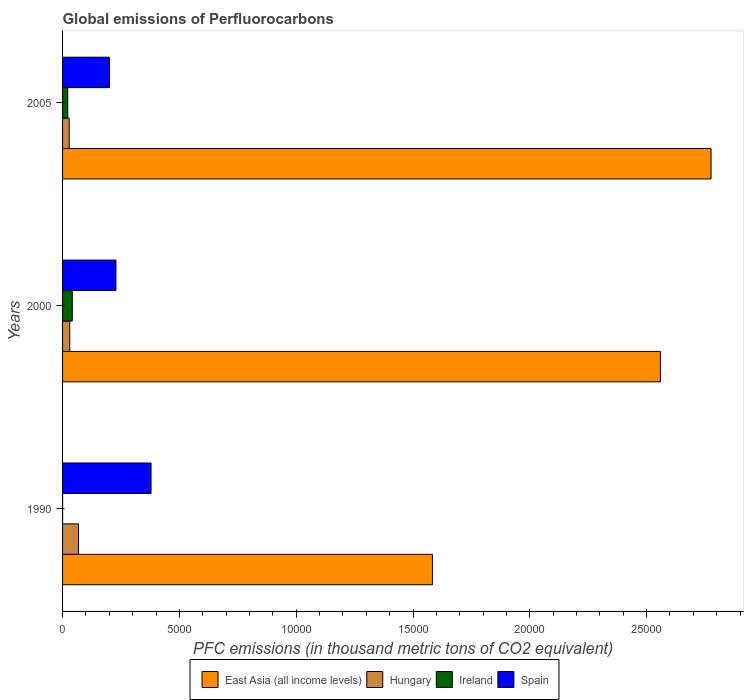How many groups of bars are there?
Give a very brief answer. 3. Are the number of bars on each tick of the Y-axis equal?
Your answer should be compact. Yes. How many bars are there on the 2nd tick from the bottom?
Your answer should be compact. 4. What is the global emissions of Perfluorocarbons in East Asia (all income levels) in 2005?
Give a very brief answer. 2.78e+04. Across all years, what is the maximum global emissions of Perfluorocarbons in Spain?
Keep it short and to the point. 3787.4. Across all years, what is the minimum global emissions of Perfluorocarbons in East Asia (all income levels)?
Give a very brief answer. 1.58e+04. In which year was the global emissions of Perfluorocarbons in Ireland maximum?
Give a very brief answer. 2000. In which year was the global emissions of Perfluorocarbons in Spain minimum?
Make the answer very short. 2005. What is the total global emissions of Perfluorocarbons in East Asia (all income levels) in the graph?
Ensure brevity in your answer.  6.92e+04. What is the difference between the global emissions of Perfluorocarbons in Hungary in 2000 and that in 2005?
Offer a terse response. 24.8. What is the difference between the global emissions of Perfluorocarbons in East Asia (all income levels) in 1990 and the global emissions of Perfluorocarbons in Spain in 2005?
Provide a short and direct response. 1.38e+04. What is the average global emissions of Perfluorocarbons in Spain per year?
Ensure brevity in your answer.  2694.07. In the year 1990, what is the difference between the global emissions of Perfluorocarbons in Hungary and global emissions of Perfluorocarbons in Ireland?
Make the answer very short. 681.9. In how many years, is the global emissions of Perfluorocarbons in East Asia (all income levels) greater than 26000 thousand metric tons?
Your answer should be compact. 1. What is the ratio of the global emissions of Perfluorocarbons in East Asia (all income levels) in 1990 to that in 2005?
Keep it short and to the point. 0.57. Is the global emissions of Perfluorocarbons in Hungary in 2000 less than that in 2005?
Offer a terse response. No. What is the difference between the highest and the second highest global emissions of Perfluorocarbons in Spain?
Offer a very short reply. 1503.6. What is the difference between the highest and the lowest global emissions of Perfluorocarbons in Spain?
Offer a very short reply. 1776.4. Is it the case that in every year, the sum of the global emissions of Perfluorocarbons in Ireland and global emissions of Perfluorocarbons in Spain is greater than the sum of global emissions of Perfluorocarbons in East Asia (all income levels) and global emissions of Perfluorocarbons in Hungary?
Your answer should be compact. Yes. What does the 3rd bar from the top in 2005 represents?
Make the answer very short. Hungary. What does the 1st bar from the bottom in 1990 represents?
Offer a very short reply. East Asia (all income levels). Is it the case that in every year, the sum of the global emissions of Perfluorocarbons in Ireland and global emissions of Perfluorocarbons in Spain is greater than the global emissions of Perfluorocarbons in East Asia (all income levels)?
Give a very brief answer. No. How many bars are there?
Provide a succinct answer. 12. Are all the bars in the graph horizontal?
Provide a short and direct response. Yes. How many years are there in the graph?
Offer a terse response. 3. Are the values on the major ticks of X-axis written in scientific E-notation?
Provide a short and direct response. No. Does the graph contain grids?
Offer a very short reply. No. How many legend labels are there?
Offer a very short reply. 4. What is the title of the graph?
Offer a terse response. Global emissions of Perfluorocarbons. Does "Cameroon" appear as one of the legend labels in the graph?
Offer a terse response. No. What is the label or title of the X-axis?
Give a very brief answer. PFC emissions (in thousand metric tons of CO2 equivalent). What is the label or title of the Y-axis?
Keep it short and to the point. Years. What is the PFC emissions (in thousand metric tons of CO2 equivalent) in East Asia (all income levels) in 1990?
Ensure brevity in your answer.  1.58e+04. What is the PFC emissions (in thousand metric tons of CO2 equivalent) in Hungary in 1990?
Your response must be concise. 683.3. What is the PFC emissions (in thousand metric tons of CO2 equivalent) of Spain in 1990?
Keep it short and to the point. 3787.4. What is the PFC emissions (in thousand metric tons of CO2 equivalent) of East Asia (all income levels) in 2000?
Your answer should be compact. 2.56e+04. What is the PFC emissions (in thousand metric tons of CO2 equivalent) of Hungary in 2000?
Offer a terse response. 308.5. What is the PFC emissions (in thousand metric tons of CO2 equivalent) in Ireland in 2000?
Keep it short and to the point. 415.6. What is the PFC emissions (in thousand metric tons of CO2 equivalent) of Spain in 2000?
Your answer should be very brief. 2283.8. What is the PFC emissions (in thousand metric tons of CO2 equivalent) in East Asia (all income levels) in 2005?
Provide a succinct answer. 2.78e+04. What is the PFC emissions (in thousand metric tons of CO2 equivalent) in Hungary in 2005?
Provide a succinct answer. 283.7. What is the PFC emissions (in thousand metric tons of CO2 equivalent) in Ireland in 2005?
Give a very brief answer. 221.8. What is the PFC emissions (in thousand metric tons of CO2 equivalent) of Spain in 2005?
Offer a terse response. 2011. Across all years, what is the maximum PFC emissions (in thousand metric tons of CO2 equivalent) of East Asia (all income levels)?
Offer a terse response. 2.78e+04. Across all years, what is the maximum PFC emissions (in thousand metric tons of CO2 equivalent) in Hungary?
Provide a short and direct response. 683.3. Across all years, what is the maximum PFC emissions (in thousand metric tons of CO2 equivalent) of Ireland?
Your response must be concise. 415.6. Across all years, what is the maximum PFC emissions (in thousand metric tons of CO2 equivalent) of Spain?
Your response must be concise. 3787.4. Across all years, what is the minimum PFC emissions (in thousand metric tons of CO2 equivalent) of East Asia (all income levels)?
Provide a short and direct response. 1.58e+04. Across all years, what is the minimum PFC emissions (in thousand metric tons of CO2 equivalent) in Hungary?
Provide a succinct answer. 283.7. Across all years, what is the minimum PFC emissions (in thousand metric tons of CO2 equivalent) of Ireland?
Offer a terse response. 1.4. Across all years, what is the minimum PFC emissions (in thousand metric tons of CO2 equivalent) of Spain?
Make the answer very short. 2011. What is the total PFC emissions (in thousand metric tons of CO2 equivalent) in East Asia (all income levels) in the graph?
Make the answer very short. 6.92e+04. What is the total PFC emissions (in thousand metric tons of CO2 equivalent) of Hungary in the graph?
Provide a short and direct response. 1275.5. What is the total PFC emissions (in thousand metric tons of CO2 equivalent) of Ireland in the graph?
Your answer should be very brief. 638.8. What is the total PFC emissions (in thousand metric tons of CO2 equivalent) of Spain in the graph?
Give a very brief answer. 8082.2. What is the difference between the PFC emissions (in thousand metric tons of CO2 equivalent) in East Asia (all income levels) in 1990 and that in 2000?
Offer a terse response. -9759.3. What is the difference between the PFC emissions (in thousand metric tons of CO2 equivalent) in Hungary in 1990 and that in 2000?
Keep it short and to the point. 374.8. What is the difference between the PFC emissions (in thousand metric tons of CO2 equivalent) in Ireland in 1990 and that in 2000?
Keep it short and to the point. -414.2. What is the difference between the PFC emissions (in thousand metric tons of CO2 equivalent) in Spain in 1990 and that in 2000?
Ensure brevity in your answer.  1503.6. What is the difference between the PFC emissions (in thousand metric tons of CO2 equivalent) in East Asia (all income levels) in 1990 and that in 2005?
Your answer should be very brief. -1.19e+04. What is the difference between the PFC emissions (in thousand metric tons of CO2 equivalent) of Hungary in 1990 and that in 2005?
Give a very brief answer. 399.6. What is the difference between the PFC emissions (in thousand metric tons of CO2 equivalent) in Ireland in 1990 and that in 2005?
Keep it short and to the point. -220.4. What is the difference between the PFC emissions (in thousand metric tons of CO2 equivalent) in Spain in 1990 and that in 2005?
Offer a terse response. 1776.4. What is the difference between the PFC emissions (in thousand metric tons of CO2 equivalent) in East Asia (all income levels) in 2000 and that in 2005?
Your answer should be compact. -2167.69. What is the difference between the PFC emissions (in thousand metric tons of CO2 equivalent) of Hungary in 2000 and that in 2005?
Your answer should be very brief. 24.8. What is the difference between the PFC emissions (in thousand metric tons of CO2 equivalent) of Ireland in 2000 and that in 2005?
Your answer should be very brief. 193.8. What is the difference between the PFC emissions (in thousand metric tons of CO2 equivalent) of Spain in 2000 and that in 2005?
Your answer should be very brief. 272.8. What is the difference between the PFC emissions (in thousand metric tons of CO2 equivalent) in East Asia (all income levels) in 1990 and the PFC emissions (in thousand metric tons of CO2 equivalent) in Hungary in 2000?
Ensure brevity in your answer.  1.55e+04. What is the difference between the PFC emissions (in thousand metric tons of CO2 equivalent) in East Asia (all income levels) in 1990 and the PFC emissions (in thousand metric tons of CO2 equivalent) in Ireland in 2000?
Give a very brief answer. 1.54e+04. What is the difference between the PFC emissions (in thousand metric tons of CO2 equivalent) of East Asia (all income levels) in 1990 and the PFC emissions (in thousand metric tons of CO2 equivalent) of Spain in 2000?
Offer a terse response. 1.35e+04. What is the difference between the PFC emissions (in thousand metric tons of CO2 equivalent) of Hungary in 1990 and the PFC emissions (in thousand metric tons of CO2 equivalent) of Ireland in 2000?
Your response must be concise. 267.7. What is the difference between the PFC emissions (in thousand metric tons of CO2 equivalent) in Hungary in 1990 and the PFC emissions (in thousand metric tons of CO2 equivalent) in Spain in 2000?
Make the answer very short. -1600.5. What is the difference between the PFC emissions (in thousand metric tons of CO2 equivalent) in Ireland in 1990 and the PFC emissions (in thousand metric tons of CO2 equivalent) in Spain in 2000?
Your response must be concise. -2282.4. What is the difference between the PFC emissions (in thousand metric tons of CO2 equivalent) in East Asia (all income levels) in 1990 and the PFC emissions (in thousand metric tons of CO2 equivalent) in Hungary in 2005?
Your answer should be compact. 1.55e+04. What is the difference between the PFC emissions (in thousand metric tons of CO2 equivalent) of East Asia (all income levels) in 1990 and the PFC emissions (in thousand metric tons of CO2 equivalent) of Ireland in 2005?
Offer a very short reply. 1.56e+04. What is the difference between the PFC emissions (in thousand metric tons of CO2 equivalent) in East Asia (all income levels) in 1990 and the PFC emissions (in thousand metric tons of CO2 equivalent) in Spain in 2005?
Your answer should be compact. 1.38e+04. What is the difference between the PFC emissions (in thousand metric tons of CO2 equivalent) of Hungary in 1990 and the PFC emissions (in thousand metric tons of CO2 equivalent) of Ireland in 2005?
Your answer should be compact. 461.5. What is the difference between the PFC emissions (in thousand metric tons of CO2 equivalent) in Hungary in 1990 and the PFC emissions (in thousand metric tons of CO2 equivalent) in Spain in 2005?
Offer a terse response. -1327.7. What is the difference between the PFC emissions (in thousand metric tons of CO2 equivalent) of Ireland in 1990 and the PFC emissions (in thousand metric tons of CO2 equivalent) of Spain in 2005?
Your answer should be very brief. -2009.6. What is the difference between the PFC emissions (in thousand metric tons of CO2 equivalent) of East Asia (all income levels) in 2000 and the PFC emissions (in thousand metric tons of CO2 equivalent) of Hungary in 2005?
Offer a terse response. 2.53e+04. What is the difference between the PFC emissions (in thousand metric tons of CO2 equivalent) in East Asia (all income levels) in 2000 and the PFC emissions (in thousand metric tons of CO2 equivalent) in Ireland in 2005?
Provide a succinct answer. 2.54e+04. What is the difference between the PFC emissions (in thousand metric tons of CO2 equivalent) in East Asia (all income levels) in 2000 and the PFC emissions (in thousand metric tons of CO2 equivalent) in Spain in 2005?
Make the answer very short. 2.36e+04. What is the difference between the PFC emissions (in thousand metric tons of CO2 equivalent) in Hungary in 2000 and the PFC emissions (in thousand metric tons of CO2 equivalent) in Ireland in 2005?
Your answer should be compact. 86.7. What is the difference between the PFC emissions (in thousand metric tons of CO2 equivalent) in Hungary in 2000 and the PFC emissions (in thousand metric tons of CO2 equivalent) in Spain in 2005?
Offer a terse response. -1702.5. What is the difference between the PFC emissions (in thousand metric tons of CO2 equivalent) of Ireland in 2000 and the PFC emissions (in thousand metric tons of CO2 equivalent) of Spain in 2005?
Make the answer very short. -1595.4. What is the average PFC emissions (in thousand metric tons of CO2 equivalent) of East Asia (all income levels) per year?
Your answer should be compact. 2.31e+04. What is the average PFC emissions (in thousand metric tons of CO2 equivalent) in Hungary per year?
Provide a succinct answer. 425.17. What is the average PFC emissions (in thousand metric tons of CO2 equivalent) of Ireland per year?
Ensure brevity in your answer.  212.93. What is the average PFC emissions (in thousand metric tons of CO2 equivalent) of Spain per year?
Your answer should be very brief. 2694.07. In the year 1990, what is the difference between the PFC emissions (in thousand metric tons of CO2 equivalent) in East Asia (all income levels) and PFC emissions (in thousand metric tons of CO2 equivalent) in Hungary?
Offer a terse response. 1.51e+04. In the year 1990, what is the difference between the PFC emissions (in thousand metric tons of CO2 equivalent) of East Asia (all income levels) and PFC emissions (in thousand metric tons of CO2 equivalent) of Ireland?
Your answer should be very brief. 1.58e+04. In the year 1990, what is the difference between the PFC emissions (in thousand metric tons of CO2 equivalent) in East Asia (all income levels) and PFC emissions (in thousand metric tons of CO2 equivalent) in Spain?
Give a very brief answer. 1.20e+04. In the year 1990, what is the difference between the PFC emissions (in thousand metric tons of CO2 equivalent) in Hungary and PFC emissions (in thousand metric tons of CO2 equivalent) in Ireland?
Provide a succinct answer. 681.9. In the year 1990, what is the difference between the PFC emissions (in thousand metric tons of CO2 equivalent) of Hungary and PFC emissions (in thousand metric tons of CO2 equivalent) of Spain?
Your answer should be very brief. -3104.1. In the year 1990, what is the difference between the PFC emissions (in thousand metric tons of CO2 equivalent) of Ireland and PFC emissions (in thousand metric tons of CO2 equivalent) of Spain?
Provide a succinct answer. -3786. In the year 2000, what is the difference between the PFC emissions (in thousand metric tons of CO2 equivalent) of East Asia (all income levels) and PFC emissions (in thousand metric tons of CO2 equivalent) of Hungary?
Make the answer very short. 2.53e+04. In the year 2000, what is the difference between the PFC emissions (in thousand metric tons of CO2 equivalent) in East Asia (all income levels) and PFC emissions (in thousand metric tons of CO2 equivalent) in Ireland?
Ensure brevity in your answer.  2.52e+04. In the year 2000, what is the difference between the PFC emissions (in thousand metric tons of CO2 equivalent) of East Asia (all income levels) and PFC emissions (in thousand metric tons of CO2 equivalent) of Spain?
Offer a terse response. 2.33e+04. In the year 2000, what is the difference between the PFC emissions (in thousand metric tons of CO2 equivalent) of Hungary and PFC emissions (in thousand metric tons of CO2 equivalent) of Ireland?
Ensure brevity in your answer.  -107.1. In the year 2000, what is the difference between the PFC emissions (in thousand metric tons of CO2 equivalent) of Hungary and PFC emissions (in thousand metric tons of CO2 equivalent) of Spain?
Offer a terse response. -1975.3. In the year 2000, what is the difference between the PFC emissions (in thousand metric tons of CO2 equivalent) in Ireland and PFC emissions (in thousand metric tons of CO2 equivalent) in Spain?
Offer a terse response. -1868.2. In the year 2005, what is the difference between the PFC emissions (in thousand metric tons of CO2 equivalent) in East Asia (all income levels) and PFC emissions (in thousand metric tons of CO2 equivalent) in Hungary?
Give a very brief answer. 2.75e+04. In the year 2005, what is the difference between the PFC emissions (in thousand metric tons of CO2 equivalent) of East Asia (all income levels) and PFC emissions (in thousand metric tons of CO2 equivalent) of Ireland?
Your response must be concise. 2.75e+04. In the year 2005, what is the difference between the PFC emissions (in thousand metric tons of CO2 equivalent) in East Asia (all income levels) and PFC emissions (in thousand metric tons of CO2 equivalent) in Spain?
Provide a succinct answer. 2.57e+04. In the year 2005, what is the difference between the PFC emissions (in thousand metric tons of CO2 equivalent) in Hungary and PFC emissions (in thousand metric tons of CO2 equivalent) in Ireland?
Provide a succinct answer. 61.9. In the year 2005, what is the difference between the PFC emissions (in thousand metric tons of CO2 equivalent) in Hungary and PFC emissions (in thousand metric tons of CO2 equivalent) in Spain?
Your answer should be compact. -1727.3. In the year 2005, what is the difference between the PFC emissions (in thousand metric tons of CO2 equivalent) of Ireland and PFC emissions (in thousand metric tons of CO2 equivalent) of Spain?
Ensure brevity in your answer.  -1789.2. What is the ratio of the PFC emissions (in thousand metric tons of CO2 equivalent) of East Asia (all income levels) in 1990 to that in 2000?
Ensure brevity in your answer.  0.62. What is the ratio of the PFC emissions (in thousand metric tons of CO2 equivalent) in Hungary in 1990 to that in 2000?
Ensure brevity in your answer.  2.21. What is the ratio of the PFC emissions (in thousand metric tons of CO2 equivalent) in Ireland in 1990 to that in 2000?
Keep it short and to the point. 0. What is the ratio of the PFC emissions (in thousand metric tons of CO2 equivalent) in Spain in 1990 to that in 2000?
Provide a short and direct response. 1.66. What is the ratio of the PFC emissions (in thousand metric tons of CO2 equivalent) in East Asia (all income levels) in 1990 to that in 2005?
Ensure brevity in your answer.  0.57. What is the ratio of the PFC emissions (in thousand metric tons of CO2 equivalent) in Hungary in 1990 to that in 2005?
Your answer should be very brief. 2.41. What is the ratio of the PFC emissions (in thousand metric tons of CO2 equivalent) in Ireland in 1990 to that in 2005?
Your response must be concise. 0.01. What is the ratio of the PFC emissions (in thousand metric tons of CO2 equivalent) in Spain in 1990 to that in 2005?
Your answer should be compact. 1.88. What is the ratio of the PFC emissions (in thousand metric tons of CO2 equivalent) in East Asia (all income levels) in 2000 to that in 2005?
Your answer should be very brief. 0.92. What is the ratio of the PFC emissions (in thousand metric tons of CO2 equivalent) in Hungary in 2000 to that in 2005?
Your response must be concise. 1.09. What is the ratio of the PFC emissions (in thousand metric tons of CO2 equivalent) of Ireland in 2000 to that in 2005?
Provide a short and direct response. 1.87. What is the ratio of the PFC emissions (in thousand metric tons of CO2 equivalent) of Spain in 2000 to that in 2005?
Your response must be concise. 1.14. What is the difference between the highest and the second highest PFC emissions (in thousand metric tons of CO2 equivalent) in East Asia (all income levels)?
Make the answer very short. 2167.69. What is the difference between the highest and the second highest PFC emissions (in thousand metric tons of CO2 equivalent) of Hungary?
Offer a terse response. 374.8. What is the difference between the highest and the second highest PFC emissions (in thousand metric tons of CO2 equivalent) of Ireland?
Give a very brief answer. 193.8. What is the difference between the highest and the second highest PFC emissions (in thousand metric tons of CO2 equivalent) in Spain?
Keep it short and to the point. 1503.6. What is the difference between the highest and the lowest PFC emissions (in thousand metric tons of CO2 equivalent) in East Asia (all income levels)?
Ensure brevity in your answer.  1.19e+04. What is the difference between the highest and the lowest PFC emissions (in thousand metric tons of CO2 equivalent) in Hungary?
Provide a short and direct response. 399.6. What is the difference between the highest and the lowest PFC emissions (in thousand metric tons of CO2 equivalent) of Ireland?
Give a very brief answer. 414.2. What is the difference between the highest and the lowest PFC emissions (in thousand metric tons of CO2 equivalent) in Spain?
Offer a terse response. 1776.4. 